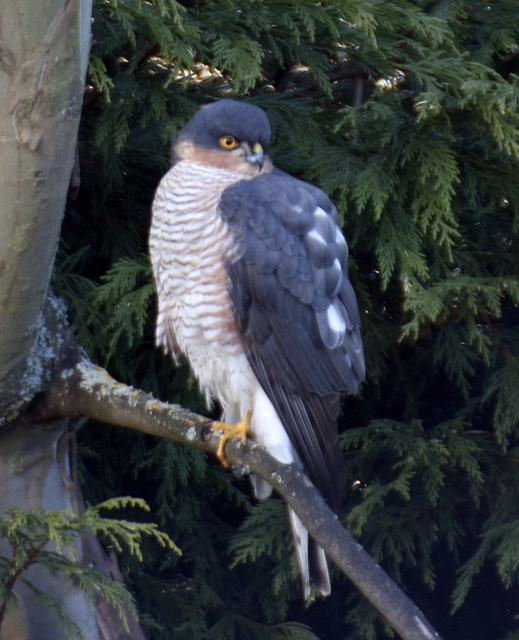<image>What kind of bird is this? I don't know what kind of bird this is. It could be a falcon, hawk, owl, condor, pigeon, or parrot. What kind of bird is this? I don't know what kind of bird it is. It can be either a falcon, hawk, owl, condor, pigeon, or parrot. 